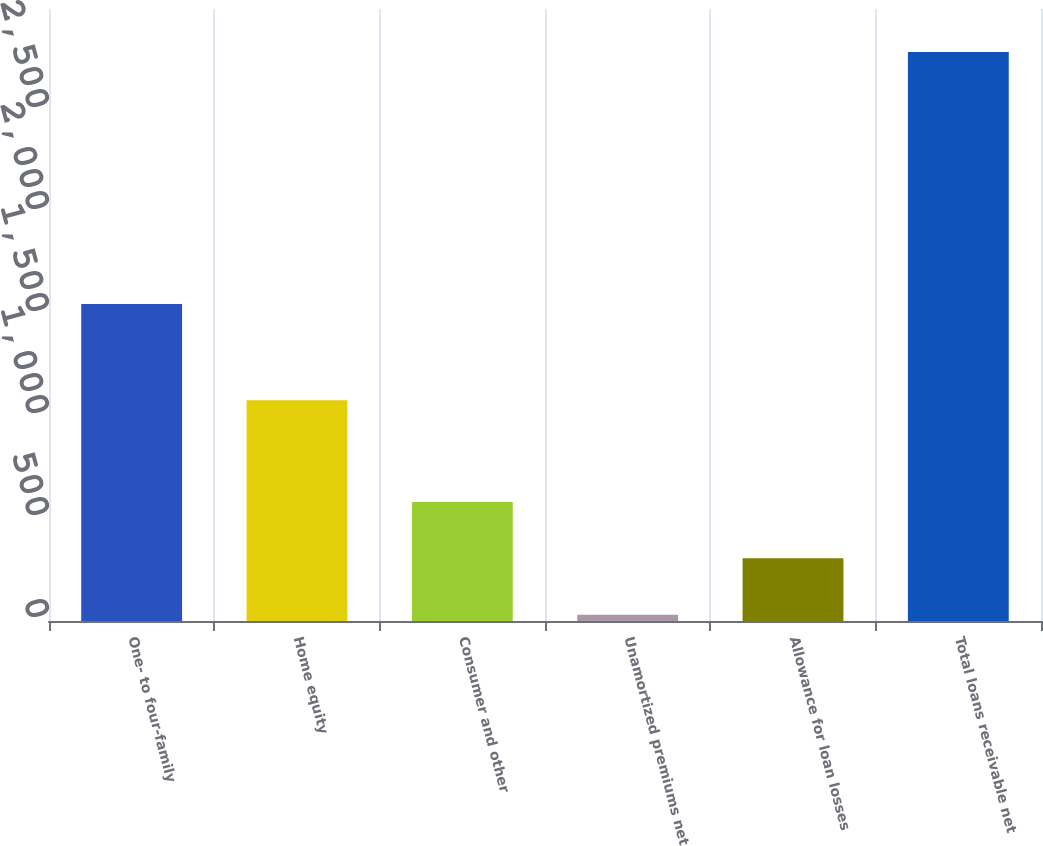Convert chart. <chart><loc_0><loc_0><loc_500><loc_500><bar_chart><fcel>One- to four-family<fcel>Home equity<fcel>Consumer and other<fcel>Unamortized premiums net<fcel>Allowance for loan losses<fcel>Total loans receivable net<nl><fcel>1554.5<fcel>1081.6<fcel>582.78<fcel>31.2<fcel>306.99<fcel>2789.1<nl></chart> 